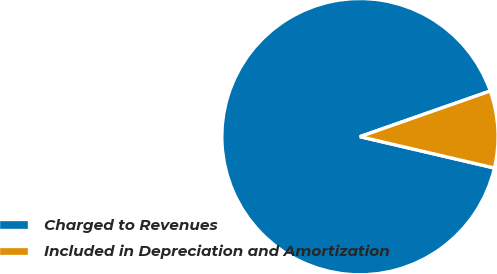Convert chart. <chart><loc_0><loc_0><loc_500><loc_500><pie_chart><fcel>Charged to Revenues<fcel>Included in Depreciation and Amortization<nl><fcel>90.99%<fcel>9.01%<nl></chart> 